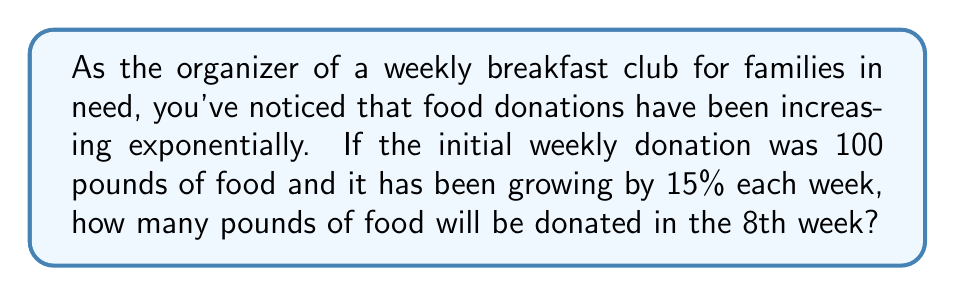What is the answer to this math problem? Let's approach this step-by-step using an exponential function:

1) The general form of an exponential growth function is:
   $A(t) = A_0 \cdot (1 + r)^t$
   
   Where:
   $A(t)$ is the amount after time $t$
   $A_0$ is the initial amount
   $r$ is the growth rate (as a decimal)
   $t$ is the time period

2) In this case:
   $A_0 = 100$ pounds (initial donation)
   $r = 0.15$ (15% growth rate)
   $t = 7$ (we want the 8th week, which is 7 periods after the initial week)

3) Plugging these values into our formula:
   $A(7) = 100 \cdot (1 + 0.15)^7$

4) Simplify inside the parentheses:
   $A(7) = 100 \cdot (1.15)^7$

5) Calculate $(1.15)^7$:
   $(1.15)^7 \approx 2.6600$

6) Multiply by the initial amount:
   $A(7) = 100 \cdot 2.6600 = 266.00$

Therefore, in the 8th week, approximately 266 pounds of food will be donated.
Answer: 266 pounds 